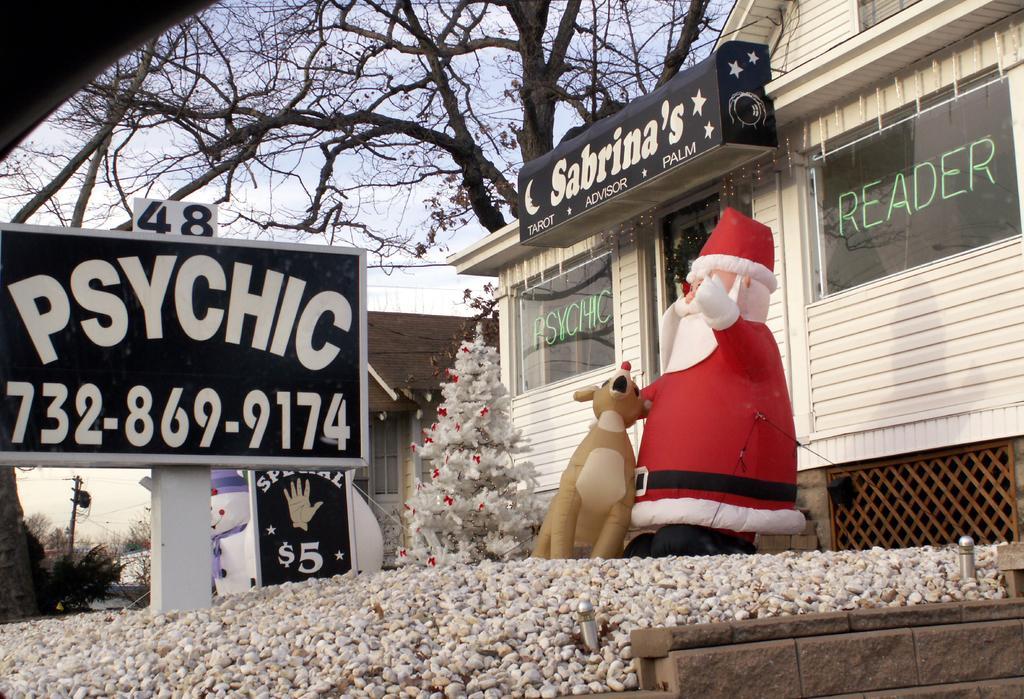How would you summarize this image in a sentence or two? In this image there is a Christmas tree, name display board, inflatable dolls in front of a house, behind the house there is a tree. 